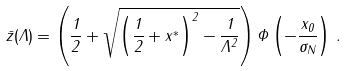<formula> <loc_0><loc_0><loc_500><loc_500>\bar { z } ( \Lambda ) = \left ( \frac { 1 } { 2 } + \sqrt { \left ( \frac { 1 } { 2 } + x ^ { * } \right ) ^ { 2 } - \frac { 1 } { \Lambda ^ { 2 } } } \right ) \Phi \left ( - \frac { x _ { 0 } } { \sigma _ { N } } \right ) \, .</formula> 